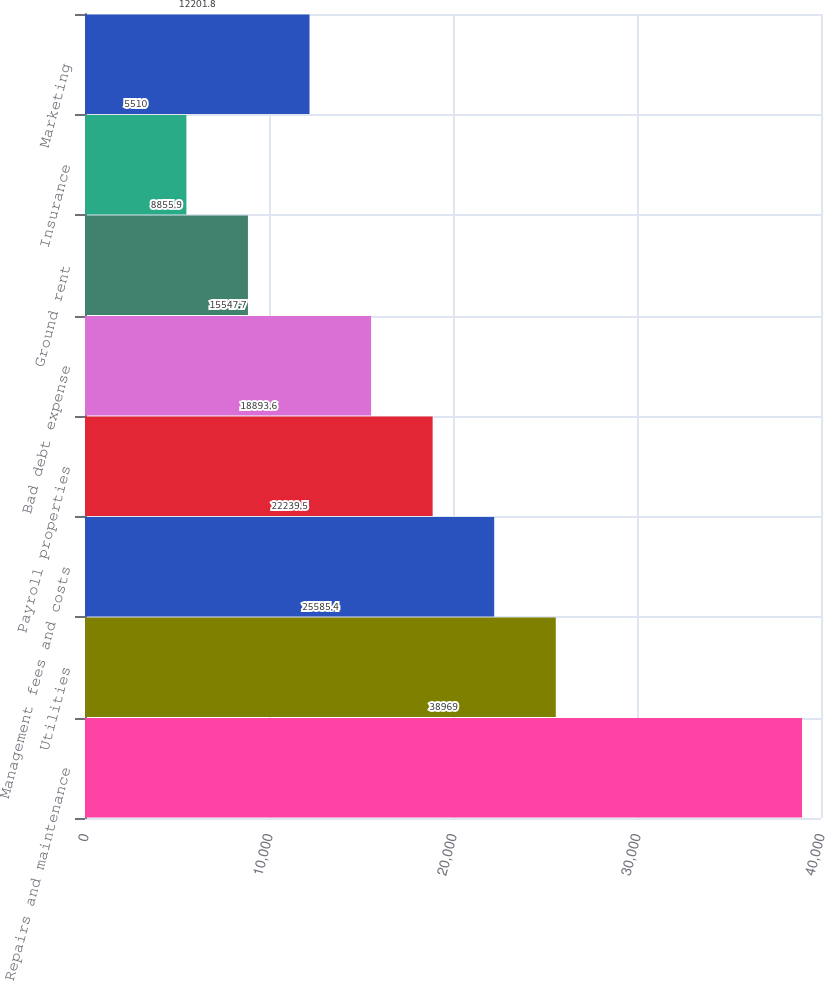Convert chart. <chart><loc_0><loc_0><loc_500><loc_500><bar_chart><fcel>Repairs and maintenance<fcel>Utilities<fcel>Management fees and costs<fcel>Payroll properties<fcel>Bad debt expense<fcel>Ground rent<fcel>Insurance<fcel>Marketing<nl><fcel>38969<fcel>25585.4<fcel>22239.5<fcel>18893.6<fcel>15547.7<fcel>8855.9<fcel>5510<fcel>12201.8<nl></chart> 